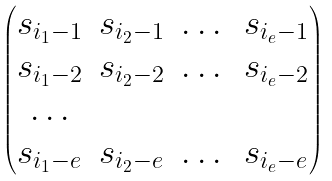<formula> <loc_0><loc_0><loc_500><loc_500>\begin{pmatrix} s _ { i _ { 1 } - 1 } & s _ { i _ { 2 } - 1 } & \dots & s _ { i _ { e } - 1 } \\ s _ { i _ { 1 } - 2 } & s _ { i _ { 2 } - 2 } & \dots & s _ { i _ { e } - 2 } \\ \dots \\ s _ { i _ { 1 } - e } & s _ { i _ { 2 } - e } & \dots & s _ { i _ { e } - e } \\ \end{pmatrix}</formula> 